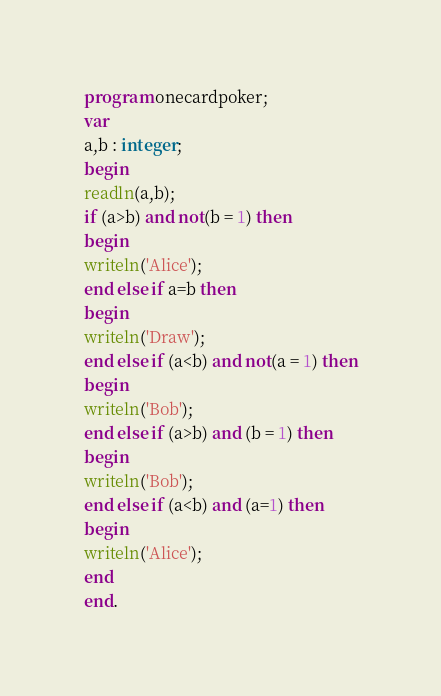Convert code to text. <code><loc_0><loc_0><loc_500><loc_500><_Pascal_>program onecardpoker;
var
a,b : integer;
begin
readln(a,b);
if (a>b) and not(b = 1) then
begin
writeln('Alice');
end else if a=b then
begin
writeln('Draw');
end else if (a<b) and not(a = 1) then
begin
writeln('Bob');
end else if (a>b) and (b = 1) then
begin
writeln('Bob');
end else if (a<b) and (a=1) then
begin
writeln('Alice');
end
end.</code> 